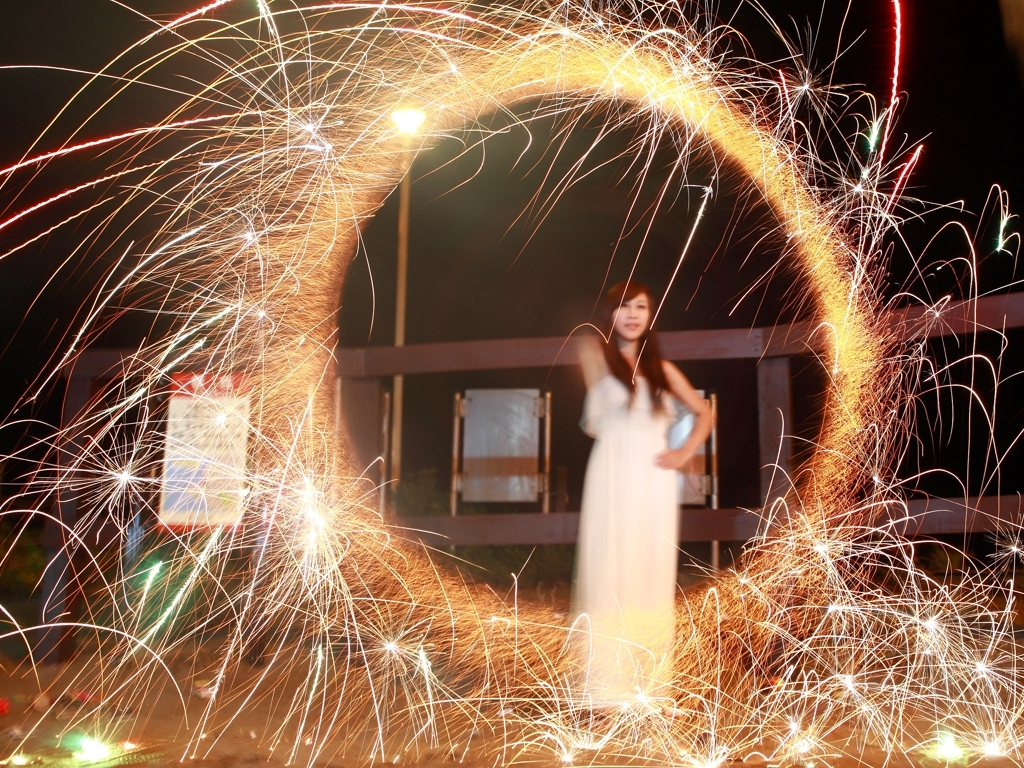What photography technique was used to capture the light trails in this image? The technique showcased in this image is called long exposure photography. The photographer has left the camera's shutter open for an extended period, allowing more light to be captured on the sensor, thus creating the light trails from moving sources of light. 